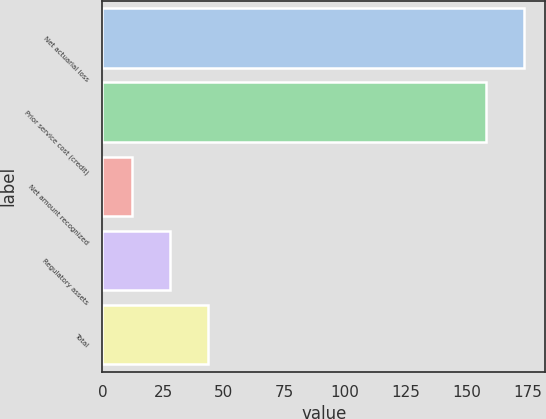<chart> <loc_0><loc_0><loc_500><loc_500><bar_chart><fcel>Net actuarial loss<fcel>Prior service cost (credit)<fcel>Net amount recognized<fcel>Regulatory assets<fcel>Total<nl><fcel>173.8<fcel>158<fcel>12<fcel>27.8<fcel>43.6<nl></chart> 